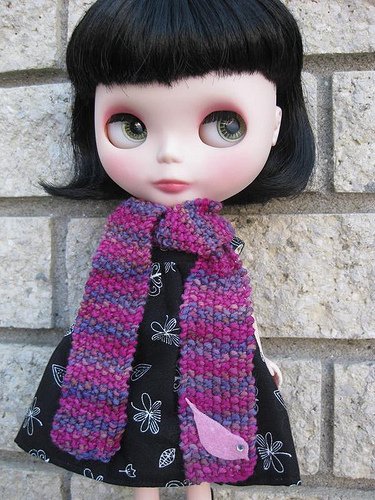<image>
Can you confirm if the doll is on the wall? Yes. Looking at the image, I can see the doll is positioned on top of the wall, with the wall providing support. 